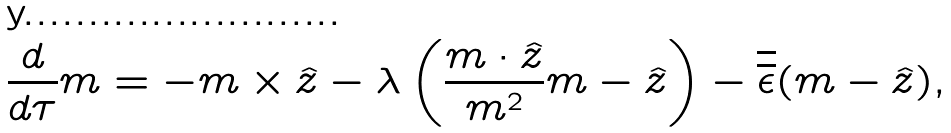Convert formula to latex. <formula><loc_0><loc_0><loc_500><loc_500>\frac { d } { d \tau } { m } = - { m } \times \hat { z } - \lambda \left ( \frac { { m } \cdot \hat { z } } { m ^ { 2 } } { m } - \hat { z } \right ) - \overline { \overline { \epsilon } } ( { m } - \hat { z } ) ,</formula> 